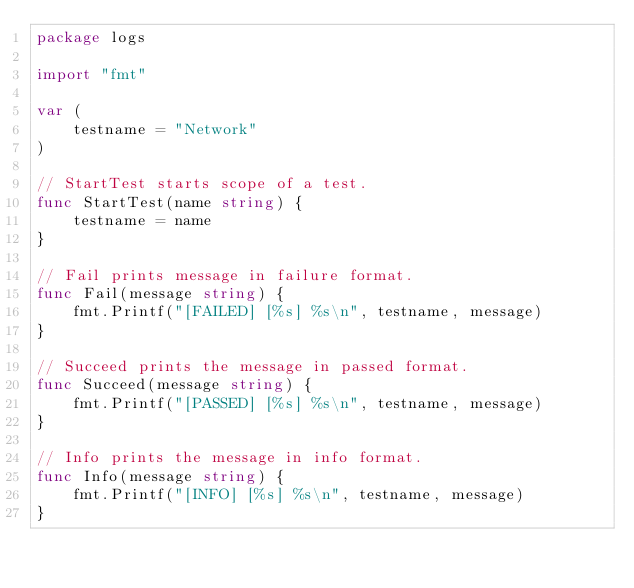Convert code to text. <code><loc_0><loc_0><loc_500><loc_500><_Go_>package logs

import "fmt"

var (
	testname = "Network"
)

// StartTest starts scope of a test.
func StartTest(name string) {
	testname = name
}

// Fail prints message in failure format.
func Fail(message string) {
	fmt.Printf("[FAILED] [%s] %s\n", testname, message)
}

// Succeed prints the message in passed format.
func Succeed(message string) {
	fmt.Printf("[PASSED] [%s] %s\n", testname, message)
}

// Info prints the message in info format.
func Info(message string) {
	fmt.Printf("[INFO] [%s] %s\n", testname, message)
}
</code> 